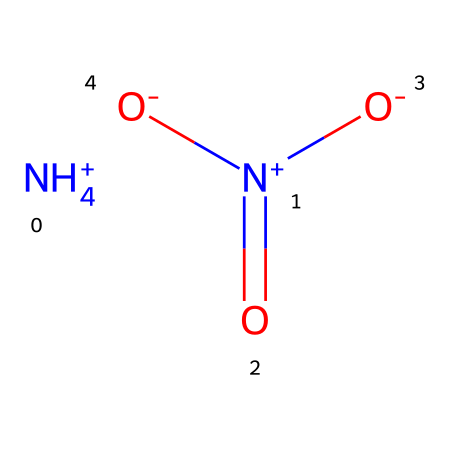What is the total number of nitrogen atoms in this chemical? By examining the SMILES representation, we can identify one ammonium ion (NH4+) that contains one nitrogen atom, and one nitrate ion (N+)(=O)([O-])[O-] that contains another nitrogen atom. Adding these gives a total of two nitrogen atoms.
Answer: 2 How many oxygen atoms are present in this chemical? The nitrate ion in the chemical structure contains three oxygen atoms, while the ammonium ion has no oxygen atoms. Therefore, the total number of oxygen atoms is three.
Answer: 3 What type of ions are present in the structure? The structure includes an ammonium ion (NH4+) and a nitrate ion (NO3-). The presence of positively charged ammonium and negatively charged nitrate identifies the chemical as a salt.
Answer: ammonium and nitrate What is the charge of the ammonium ion in this chemical? The ammonium ion (NH4+) is represented with a plus sign in the SMILES notation, indicating that it carries a positive charge of +1.
Answer: +1 What does the [N+](=O)([O-])[O-] part of the structure indicate about its oxidation state? The nitrogen atom in the nitrate ion is represented as N+, which suggests that it is in a higher oxidation state. The presence of three oxygen atoms bonded to nitrogen typically corresponds to an oxidation state of +5 for nitrogen.
Answer: +5 What is the overall charge of the compound formed by these ions? The ammonium ion has a charge of +1, and the nitrate ion has a charge of -1. Therefore, the overall charge of the compound is neutral, since +1 + (-1) equals 0.
Answer: 0 